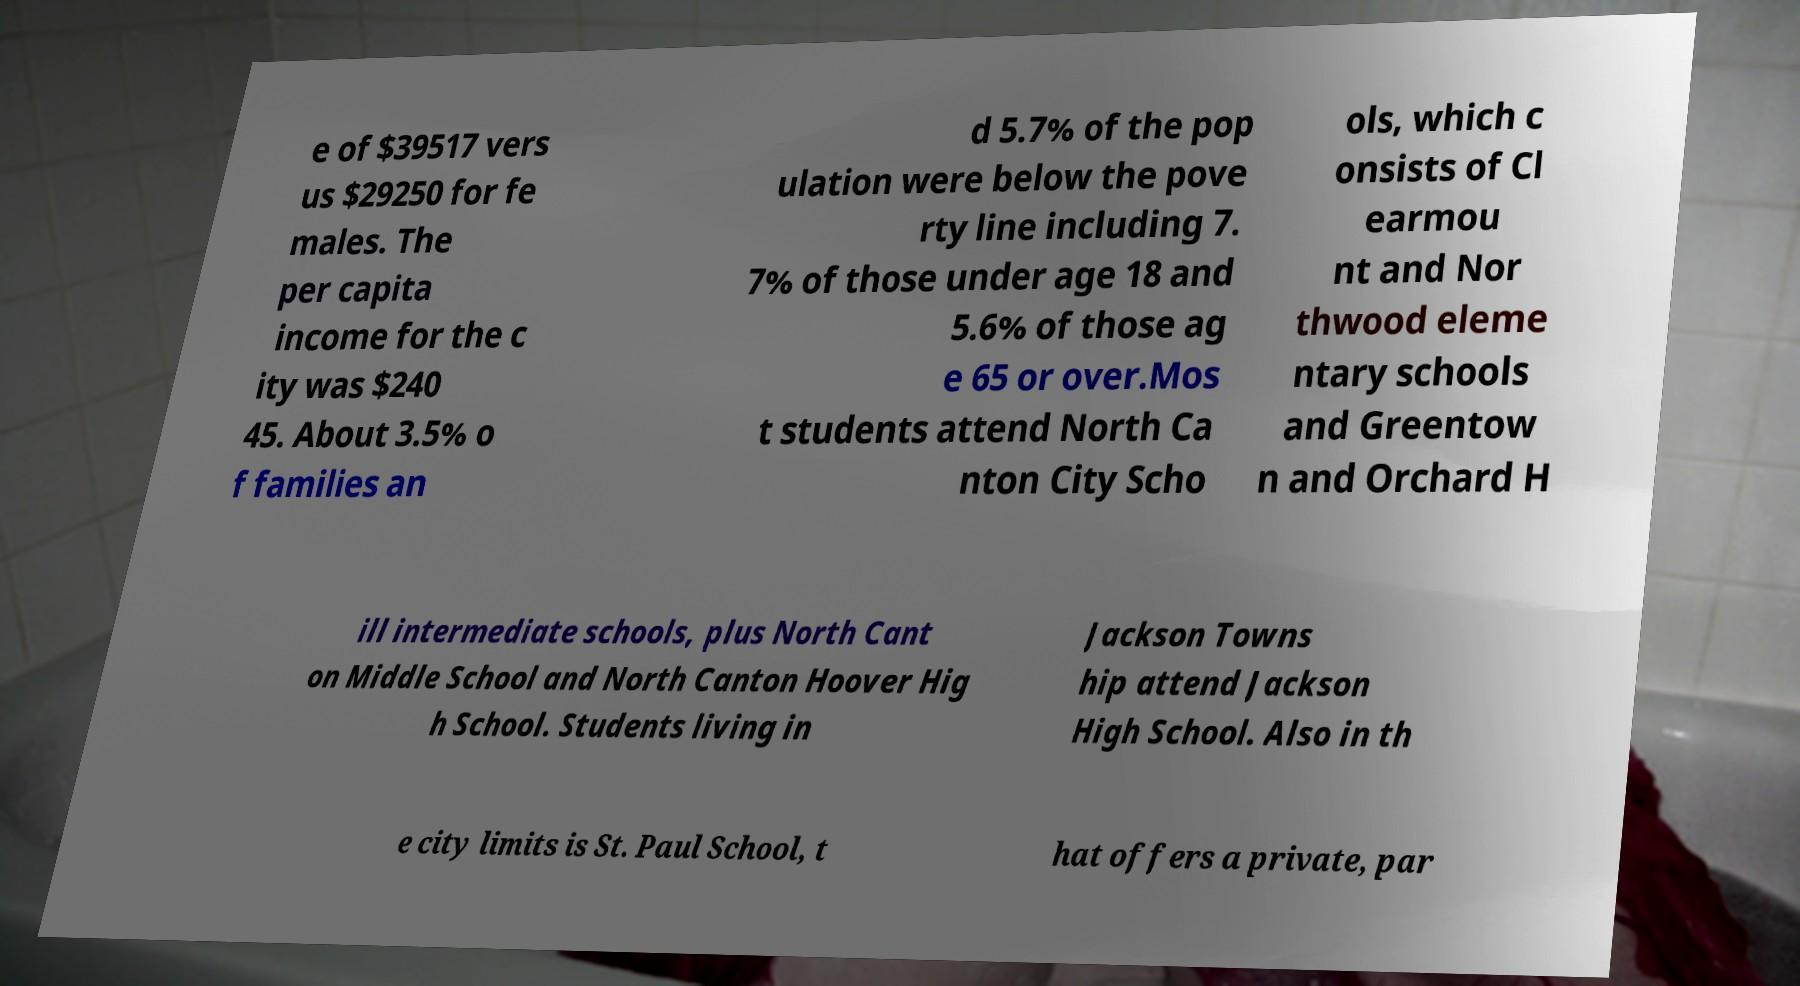Please identify and transcribe the text found in this image. e of $39517 vers us $29250 for fe males. The per capita income for the c ity was $240 45. About 3.5% o f families an d 5.7% of the pop ulation were below the pove rty line including 7. 7% of those under age 18 and 5.6% of those ag e 65 or over.Mos t students attend North Ca nton City Scho ols, which c onsists of Cl earmou nt and Nor thwood eleme ntary schools and Greentow n and Orchard H ill intermediate schools, plus North Cant on Middle School and North Canton Hoover Hig h School. Students living in Jackson Towns hip attend Jackson High School. Also in th e city limits is St. Paul School, t hat offers a private, par 